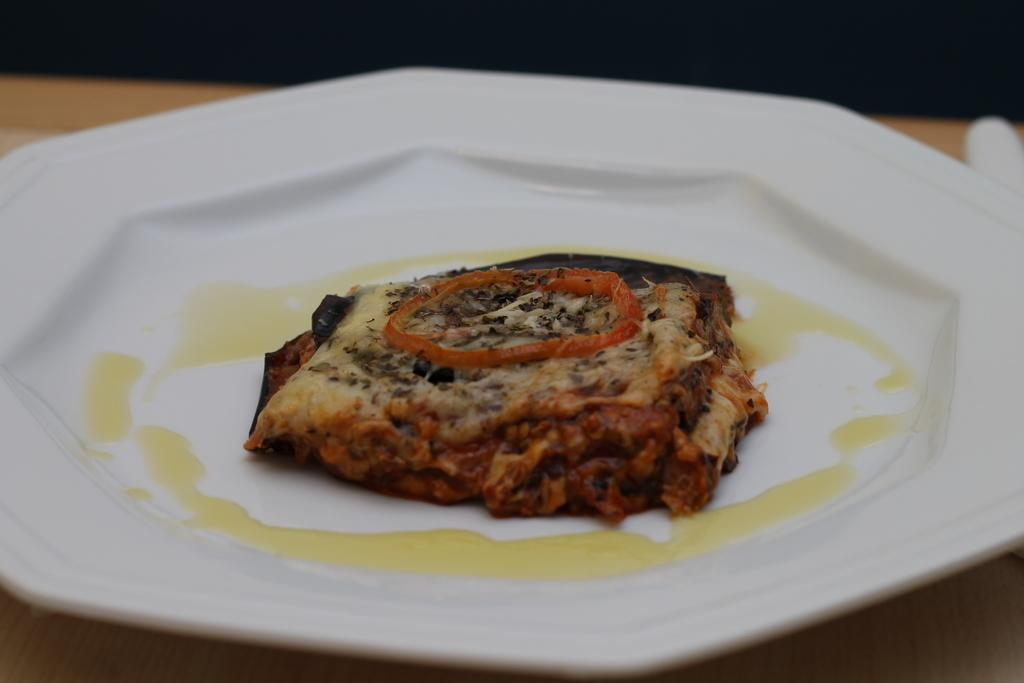What is the main subject of the image? There is a food item in the image. How is the food item presented in the image? The food item is in a plate. Where is the plate with the food item located? The plate is placed on a table. What lesson is being taught in the image? There is no lesson or teaching activity present in the image; it simply shows a food item in a plate on a table. 